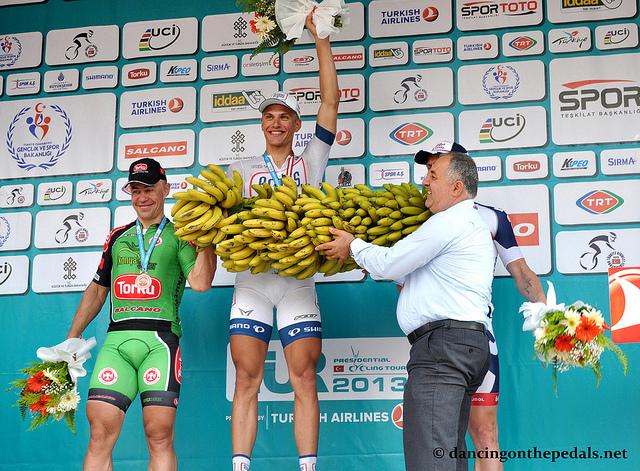How many bananas?
Short answer required. 100. What is being presented to the winner?
Be succinct. Bananas. What color uniform is the winner wearing?
Write a very short answer. White and blue. What sport is being represented?
Quick response, please. Cycling. What are the people holding?
Short answer required. Bananas. 